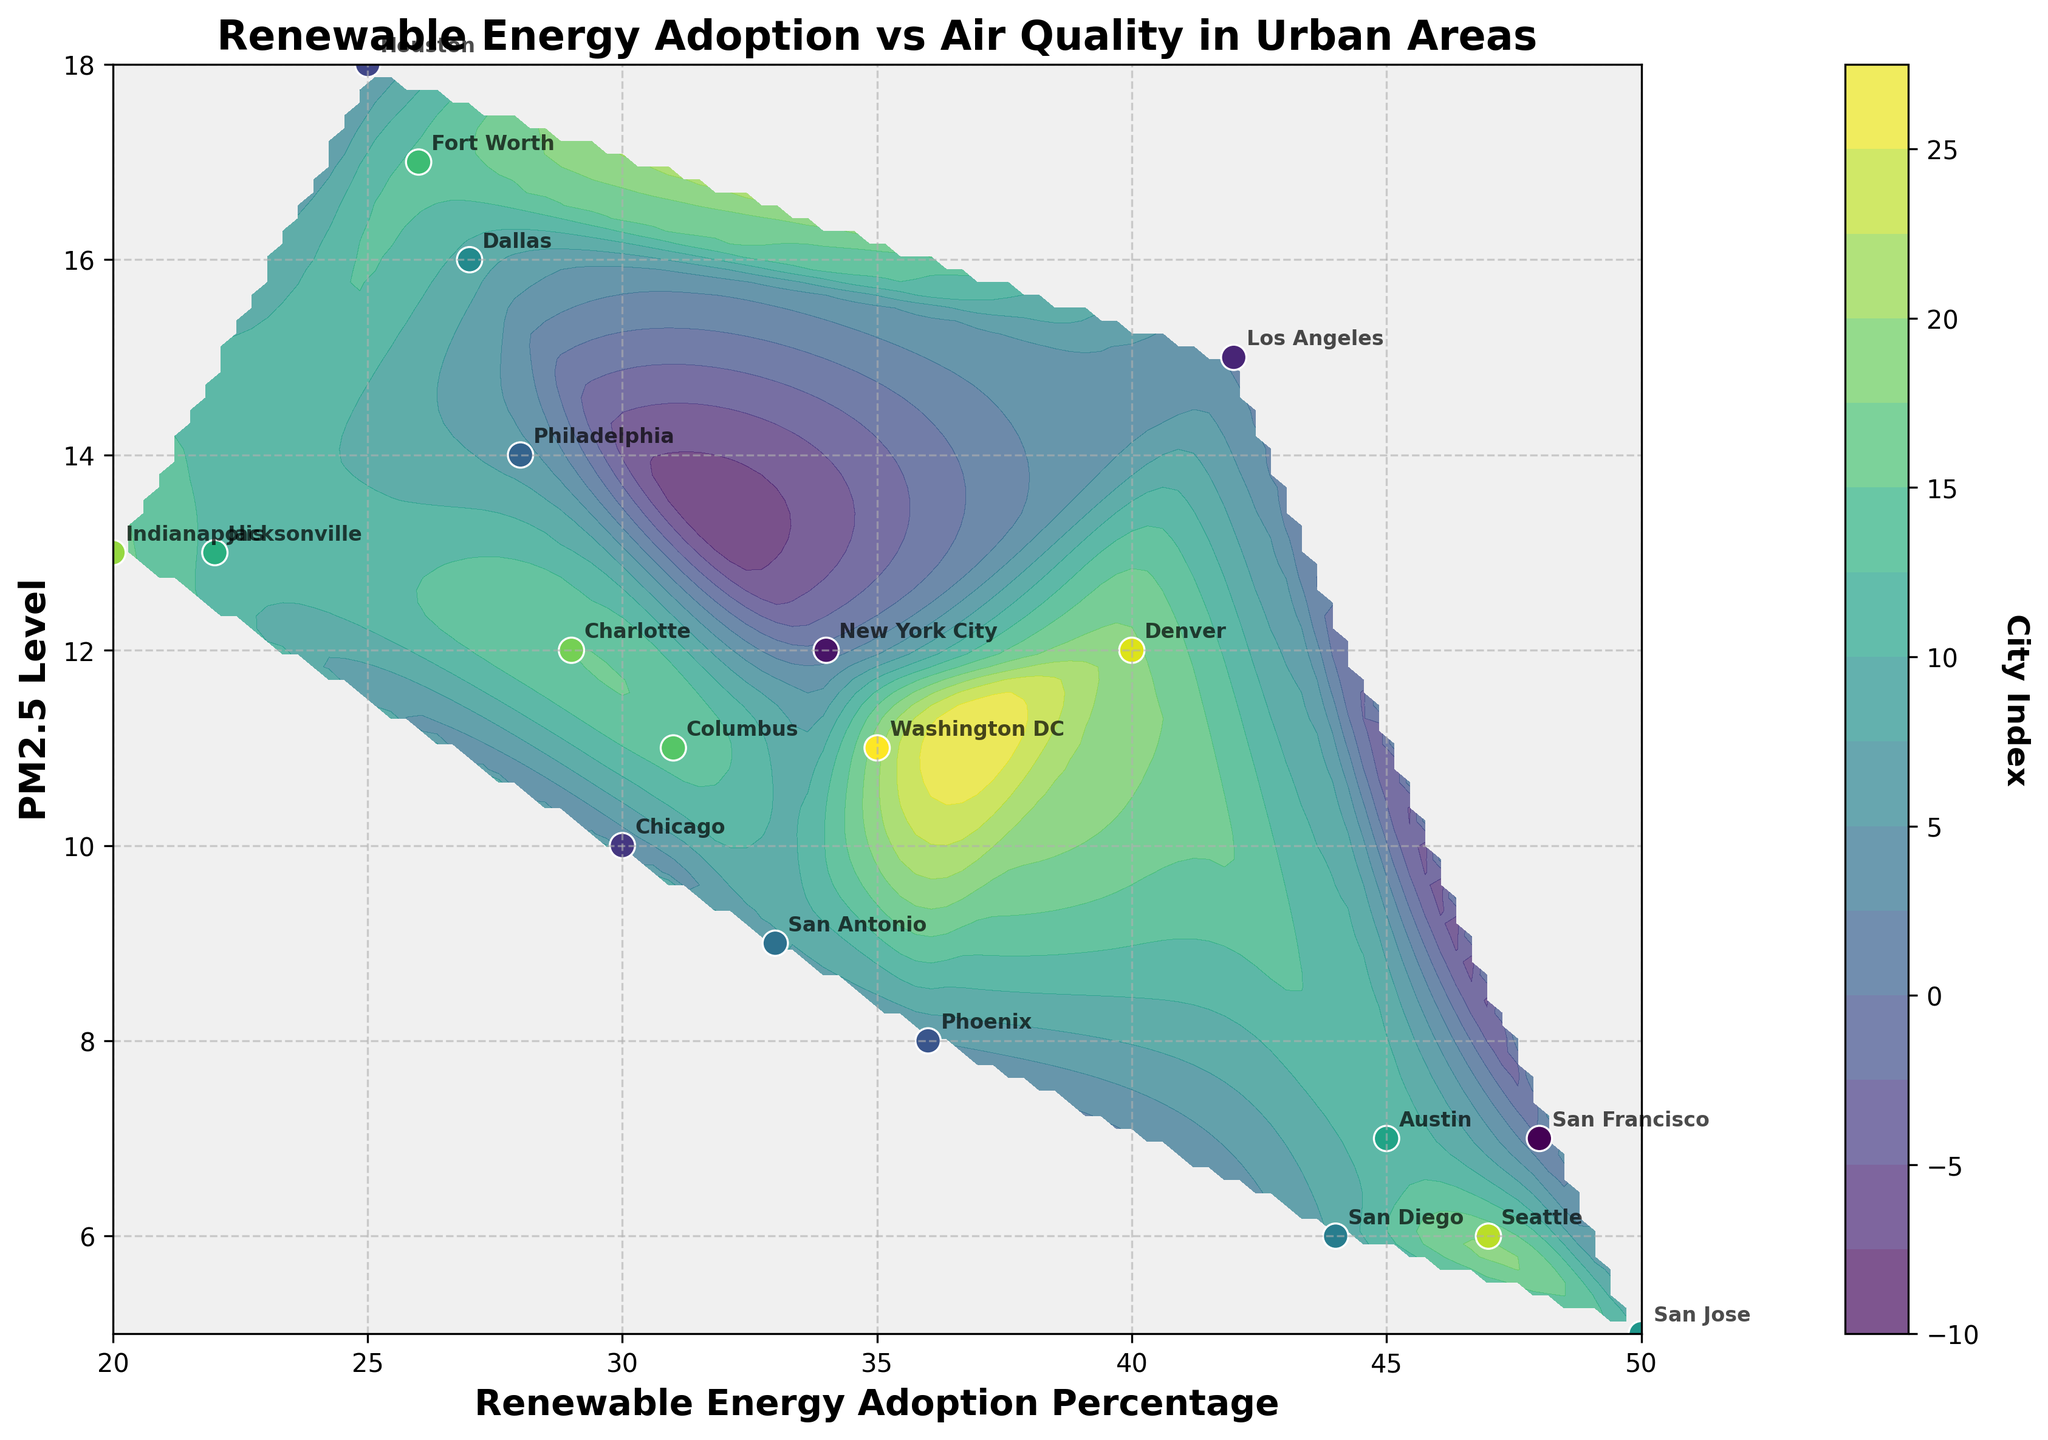What is the title of the figure? The title is written at the top of the figure. It reads "Renewable Energy Adoption vs Air Quality in Urban Areas".
Answer: Renewable Energy Adoption vs Air Quality in Urban Areas What are the x-axis and y-axis labels in the plot? The x-axis label is visible at the bottom and reads "Renewable Energy Adoption Percentage". The y-axis label on the left reads "PM2.5 Level".
Answer: Renewable Energy Adoption Percentage, PM2.5 Level How many cities are represented in the figure? Each data point in the figure represents a city. By counting the annotations, we can see there are 20 cities.
Answer: 20 Which city has the highest renewable energy adoption percentage? From the annotations, San Jose stands out as having the highest renewable energy adoption percentage, which is annotated around 50%.
Answer: San Jose Compare the PM2.5 levels of Houston and San Jose. Which city has better air quality? Houston has a PM2.5 level of 18, while San Jose has a PM2.5 level of 5. Lower PM2.5 levels indicate better air quality.
Answer: San Jose Which city has the lowest renewable energy adoption percentage and what is its PM2.5 level? Indianapolis is annotated with the lowest renewable energy adoption percentage at 20%. Its PM2.5 level is marked around 13.
Answer: Indianapolis, 13 Looking at the figure, can you identify a correlation between renewable energy adoption percentage and PM2.5 levels among urban areas? The figure shows that cities with higher renewable energy adoption percentages generally have lower PM2.5 levels, indicating a negative correlation.
Answer: Negative correlation Which city has a PM2.5 level of 15 and what is its renewable energy adoption percentage? Los Angeles has a PM2.5 level of 15, and its renewable energy adoption percentage is annotated as 42%.
Answer: Los Angeles, 42% What's the average renewable energy adoption percentage of the cities that have a PM2.5 level of 10 or lower? The cities with PM2.5 levels of 10 or lower are San Francisco (48%), San Antonio (33%), San Diego (44%), San Jose (50%), Austin (45%), and Seattle (47%). Average = (48 + 33 + 44 + 50 + 45 + 47)/6 = 44.5.
Answer: 44.5 